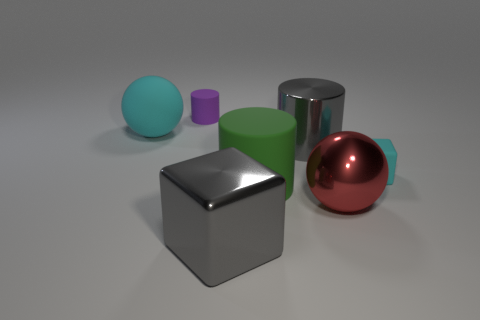Is the matte cube the same color as the large rubber ball?
Provide a succinct answer. Yes. What number of objects are green matte blocks or shiny things behind the big green thing?
Keep it short and to the point. 1. Does the cyan object to the left of the gray cube have the same material as the red object in front of the tiny matte cylinder?
Offer a very short reply. No. There is a thing that is the same color as the tiny cube; what shape is it?
Keep it short and to the point. Sphere. How many blue things are large spheres or big blocks?
Your response must be concise. 0. How big is the cyan block?
Keep it short and to the point. Small. Is the number of rubber balls that are right of the tiny cyan rubber cube greater than the number of small matte cubes?
Provide a short and direct response. No. How many small rubber cubes are in front of the red thing?
Your answer should be compact. 0. Are there any cyan rubber blocks that have the same size as the red metal sphere?
Offer a very short reply. No. The other large thing that is the same shape as the big green rubber thing is what color?
Offer a terse response. Gray. 